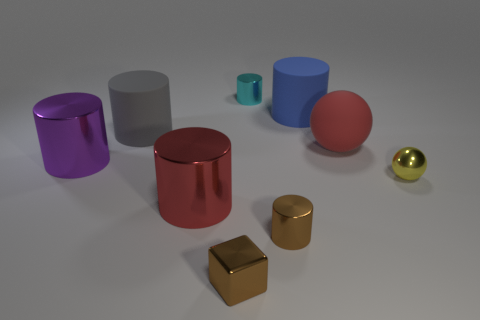Subtract all cyan cylinders. How many cylinders are left? 5 Subtract all brown cylinders. How many cylinders are left? 5 Subtract 3 cylinders. How many cylinders are left? 3 Subtract all yellow cylinders. Subtract all red blocks. How many cylinders are left? 6 Add 1 large green cubes. How many objects exist? 10 Subtract all cubes. How many objects are left? 8 Add 5 big purple blocks. How many big purple blocks exist? 5 Subtract 0 gray blocks. How many objects are left? 9 Subtract all large red matte balls. Subtract all tiny cyan things. How many objects are left? 7 Add 8 big purple metallic cylinders. How many big purple metallic cylinders are left? 9 